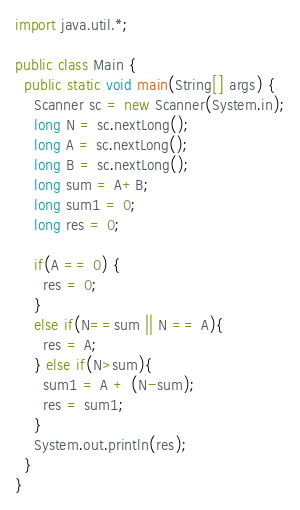<code> <loc_0><loc_0><loc_500><loc_500><_Java_>import java.util.*;

public class Main {
  public static void main(String[] args) {
    Scanner sc = new Scanner(System.in);
    long N = sc.nextLong();
    long A = sc.nextLong();
    long B = sc.nextLong();
    long sum = A+B;
    long sum1 = 0;
    long res = 0;

    if(A == 0) {
      res = 0;
    }
    else if(N==sum || N == A){
      res = A;
    } else if(N>sum){
      sum1 = A + (N-sum);
      res = sum1;
    }
    System.out.println(res);
  }
}</code> 